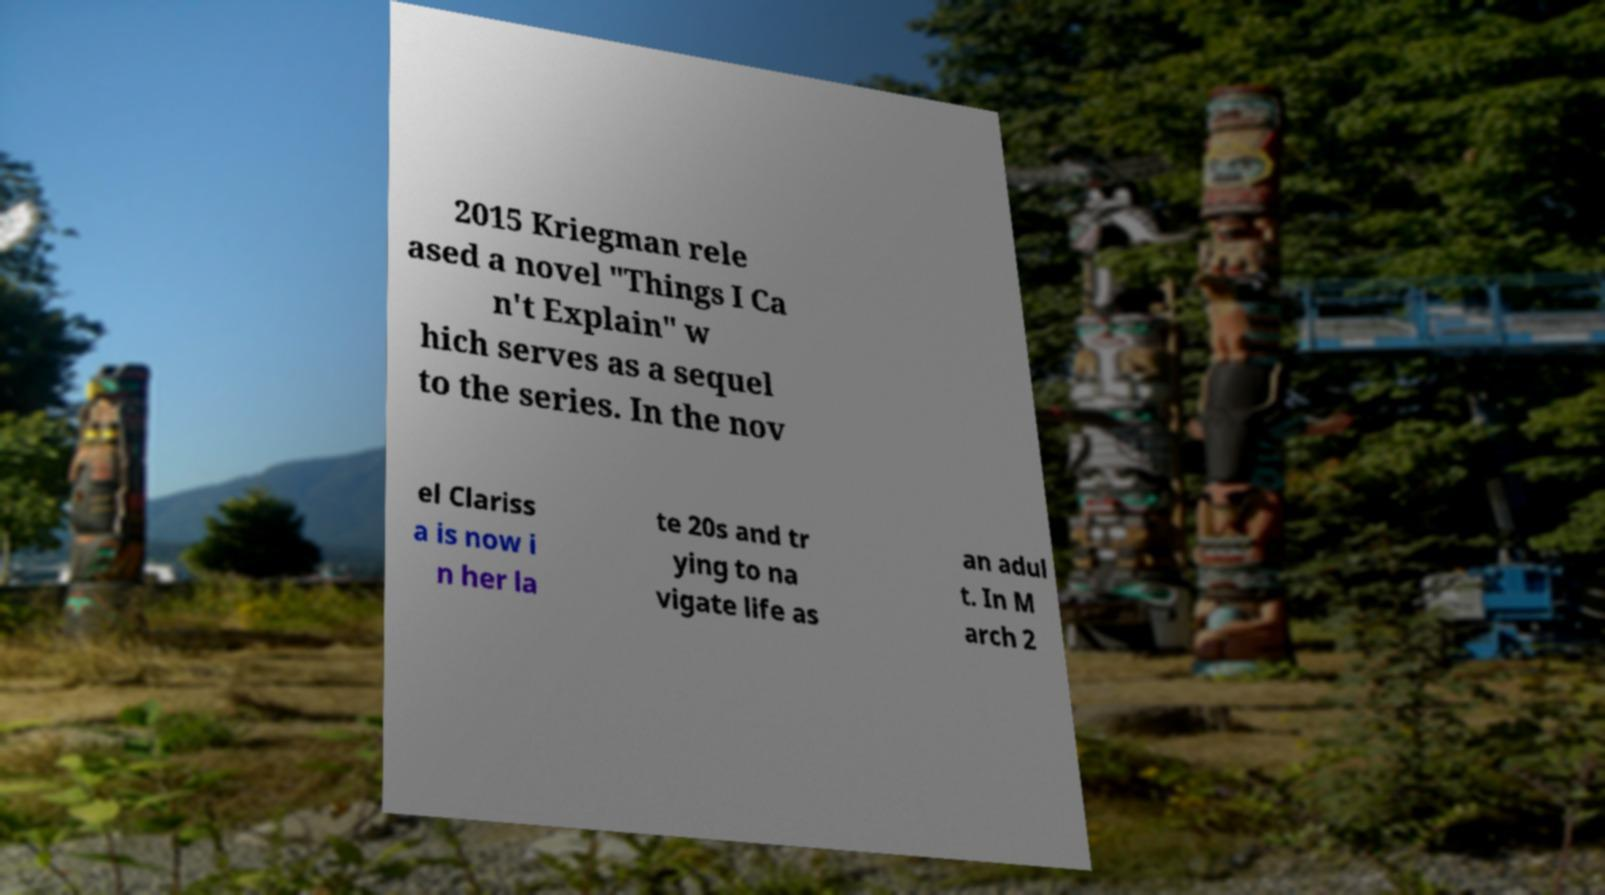There's text embedded in this image that I need extracted. Can you transcribe it verbatim? 2015 Kriegman rele ased a novel "Things I Ca n't Explain" w hich serves as a sequel to the series. In the nov el Clariss a is now i n her la te 20s and tr ying to na vigate life as an adul t. In M arch 2 